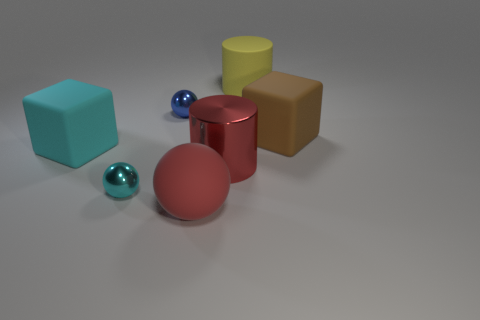Add 2 tiny matte balls. How many objects exist? 9 Subtract all cylinders. How many objects are left? 5 Add 2 metal spheres. How many metal spheres are left? 4 Add 1 big brown things. How many big brown things exist? 2 Subtract 0 gray cubes. How many objects are left? 7 Subtract all blue objects. Subtract all big red spheres. How many objects are left? 5 